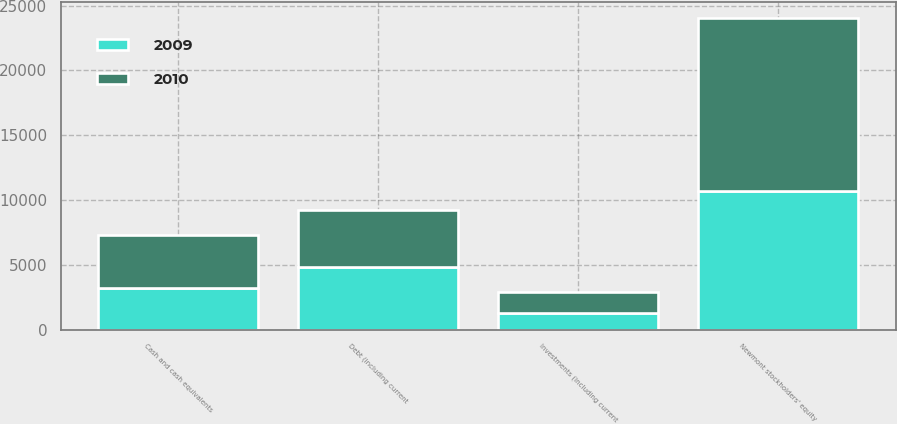Convert chart to OTSL. <chart><loc_0><loc_0><loc_500><loc_500><stacked_bar_chart><ecel><fcel>Debt (including current<fcel>Newmont stockholders' equity<fcel>Cash and cash equivalents<fcel>Investments (including current<nl><fcel>2010<fcel>4441<fcel>13345<fcel>4056<fcel>1681<nl><fcel>2009<fcel>4809<fcel>10703<fcel>3215<fcel>1242<nl></chart> 